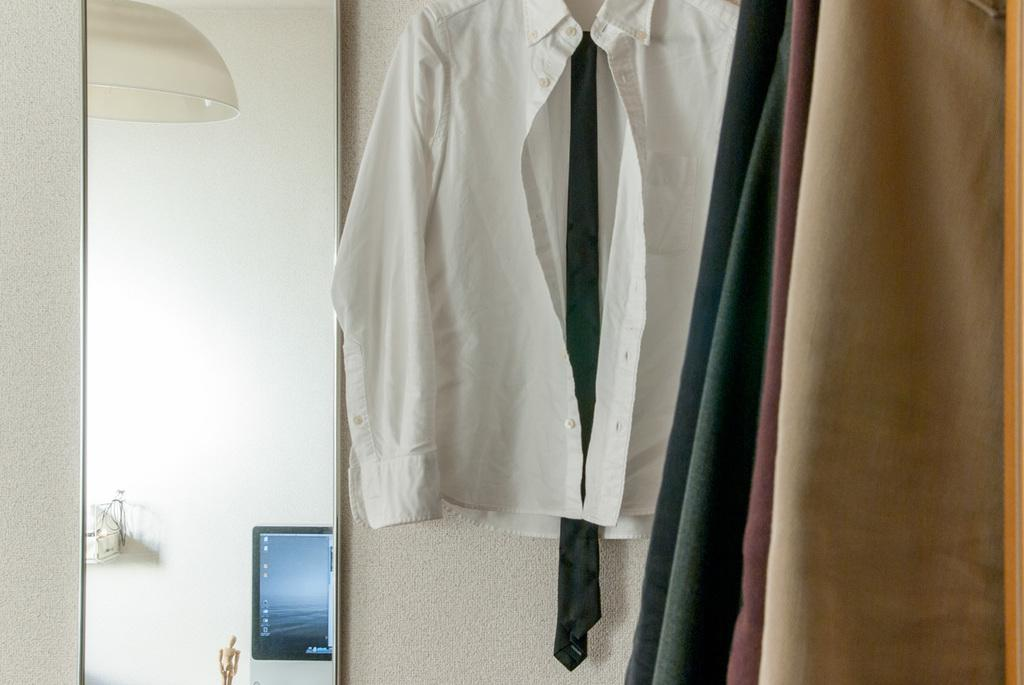What is hanging on the wall in the image? There are clothes hanging on the wall in the image. What can be seen on the left side of the image? There is a wall visible on the left side of the image. Can you describe any other objects present in the image? Unfortunately, the provided facts do not give any information about other objects inanimate objects in the image. What type of cream is being spread on the map in the image? There is no map or cream present in the image. How does the motion of the objects in the image contribute to the overall scene? The provided facts do not give any information about the motion of objects in the image. 